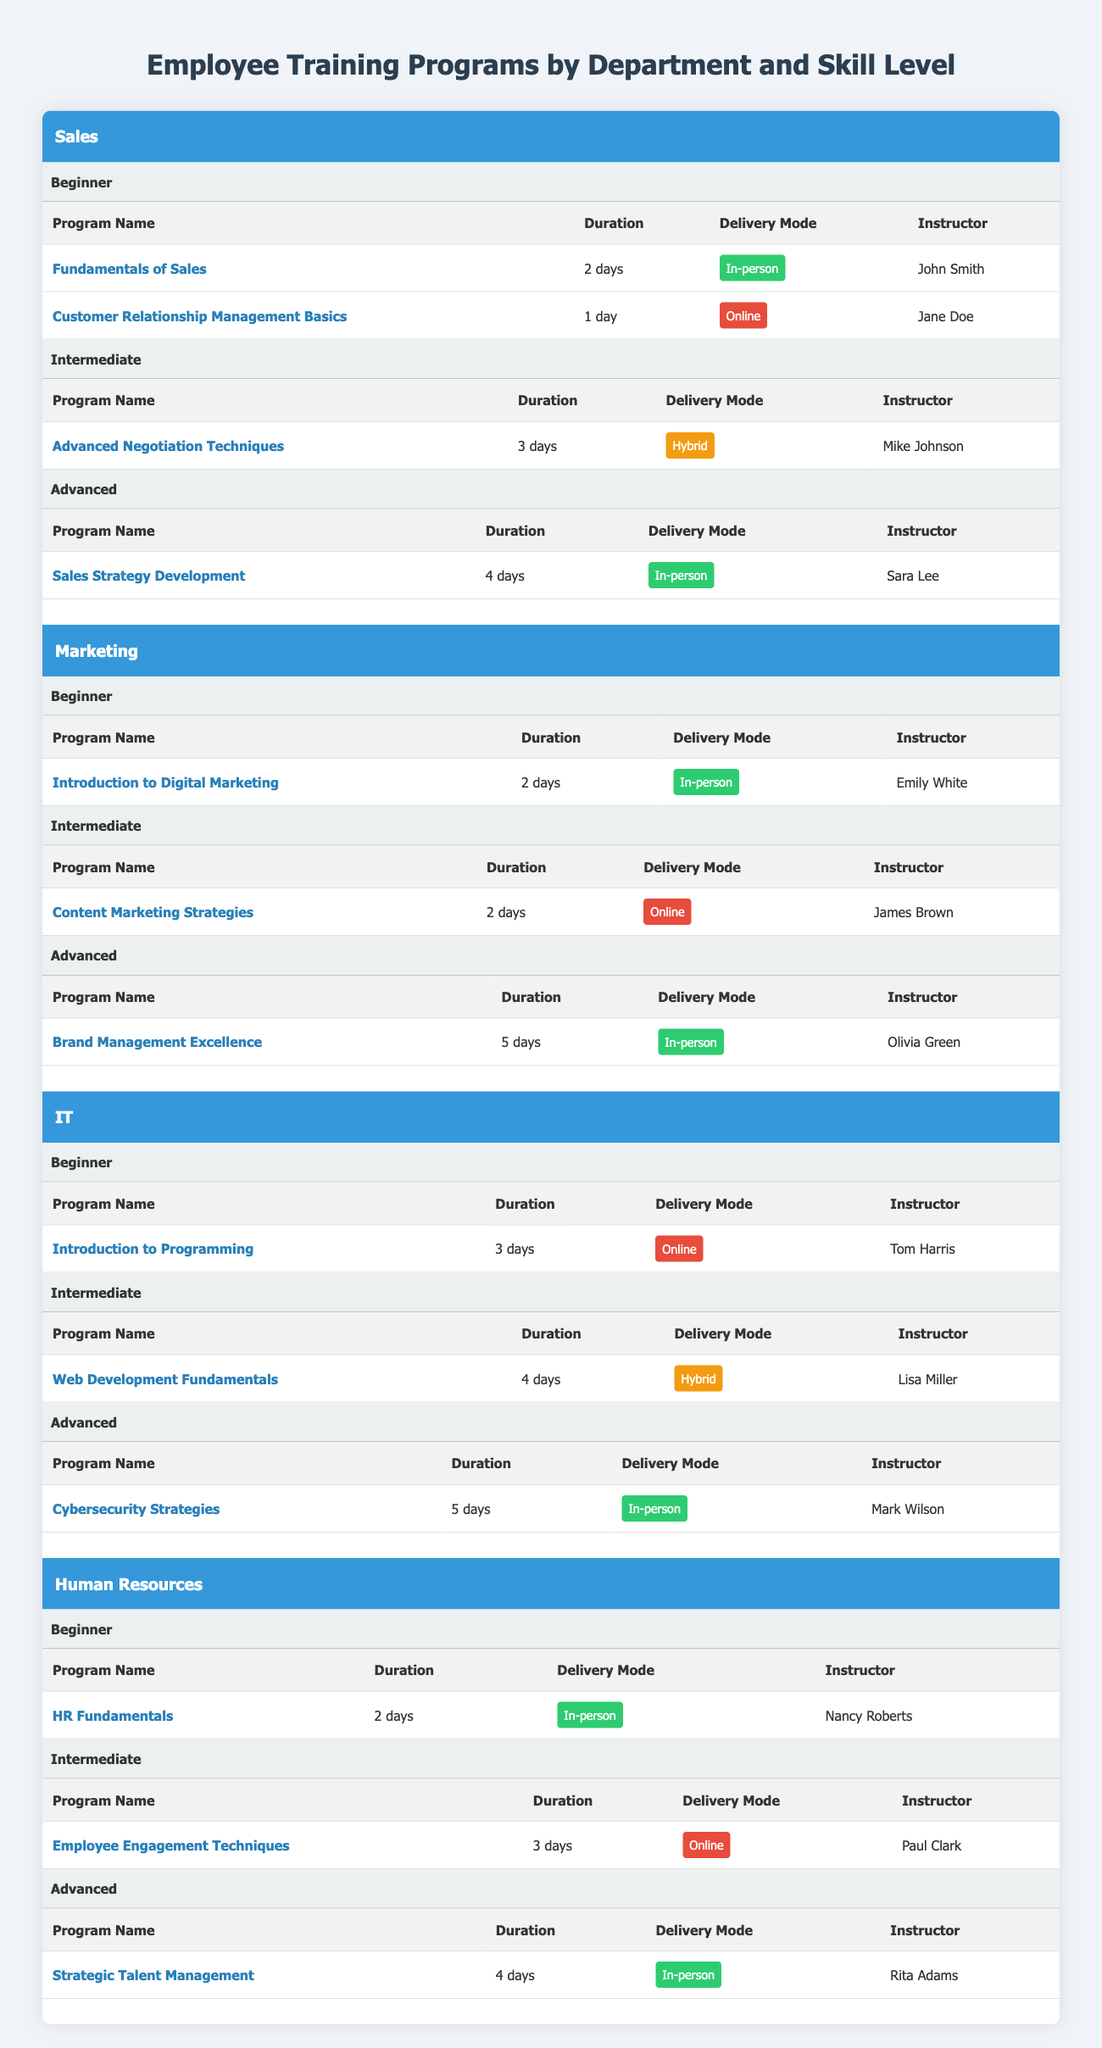What are the delivery modes used in the Sales department training programs? The Sales department has three training programs listed under different skill levels. The delivery modes for these programs are: "In-person" for "Fundamentals of Sales" and "Sales Strategy Development," "Online" for "Customer Relationship Management Basics," and "Hybrid" for "Advanced Negotiation Techniques."
Answer: In-person, Online, Hybrid Which instructor teaches the "Introduction to Programming" course? The course "Introduction to Programming" listed under the IT department indicates that Tom Harris is the instructor for this program.
Answer: Tom Harris Is there a digital marketing program for beginners? According to the Marketing department section, there is indeed a program titled "Introduction to Digital Marketing" specifically for beginners.
Answer: Yes What is the total duration of all training programs offered for the IT department? The IT department offers three programs: "Introduction to Programming" (3 days), "Web Development Fundamentals" (4 days), and "Cybersecurity Strategies" (5 days). To find the total duration, we sum these: 3 + 4 + 5 = 12 days.
Answer: 12 days Are all the advanced training programs in the Human Resources department delivered in-person? The advanced training program in the Human Resources department, "Strategic Talent Management," is delivered in-person; hence, it matches the query. Confirming for all advanced programs shows that both "Advanced Negotiation Techniques" in Sales and "Cybersecurity Strategies" in IT are also in-person. Thus, all advanced HR programs are in-person.
Answer: Yes Which department has a program that takes the longest to complete, and what is that program? By reviewing all department programs, the longest program is "Brand Management Excellence" in the Marketing department, which lasts 5 days. Other advanced programs in the IT and HR departments also last 5 days, but Marketing is the first listed.
Answer: Marketing, Brand Management Excellence What is the average duration of the advanced training programs across all departments? To find the average duration, we first need the durations for each advanced program: "Sales Strategy Development" (4 days), "Brand Management Excellence" (5 days), "Cybersecurity Strategies" (5 days), and "Strategic Talent Management" (4 days). The total duration is 4 + 5 + 5 + 4 = 18 days, and since there are 4 programs, the average is 18 / 4 = 4.5 days.
Answer: 4.5 days Are there multiple instructors teaching beginner's programs in different departments? Yes, looking through the beginner's programs, we see different instructors: "Fundamentals of Sales" by John Smith, "Introduction to Digital Marketing" by Emily White, and "Introduction to Programming" by Tom Harris. This confirms multiple instructors.
Answer: Yes 